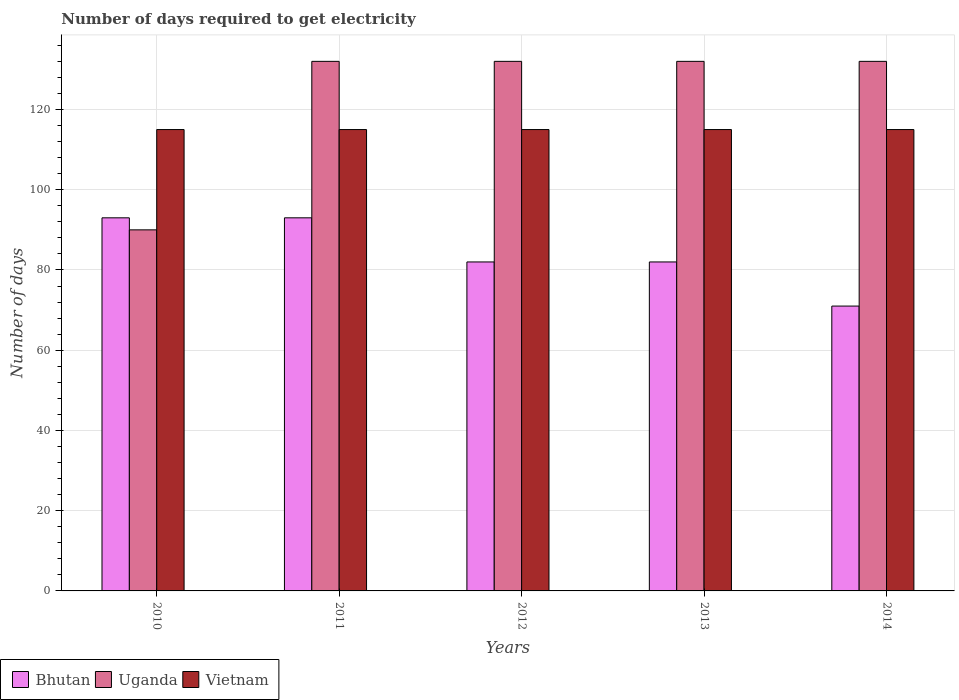Are the number of bars on each tick of the X-axis equal?
Provide a succinct answer. Yes. How many bars are there on the 5th tick from the left?
Ensure brevity in your answer.  3. What is the label of the 5th group of bars from the left?
Keep it short and to the point. 2014. In how many cases, is the number of bars for a given year not equal to the number of legend labels?
Make the answer very short. 0. What is the number of days required to get electricity in in Uganda in 2014?
Give a very brief answer. 132. Across all years, what is the maximum number of days required to get electricity in in Vietnam?
Make the answer very short. 115. Across all years, what is the minimum number of days required to get electricity in in Uganda?
Provide a short and direct response. 90. In which year was the number of days required to get electricity in in Vietnam maximum?
Your answer should be compact. 2010. In which year was the number of days required to get electricity in in Uganda minimum?
Give a very brief answer. 2010. What is the total number of days required to get electricity in in Vietnam in the graph?
Provide a succinct answer. 575. What is the difference between the number of days required to get electricity in in Uganda in 2011 and that in 2014?
Your response must be concise. 0. What is the difference between the number of days required to get electricity in in Bhutan in 2011 and the number of days required to get electricity in in Vietnam in 2010?
Your response must be concise. -22. What is the average number of days required to get electricity in in Bhutan per year?
Provide a succinct answer. 84.2. In the year 2013, what is the difference between the number of days required to get electricity in in Vietnam and number of days required to get electricity in in Uganda?
Your answer should be compact. -17. In how many years, is the number of days required to get electricity in in Bhutan greater than 8 days?
Your answer should be compact. 5. What is the ratio of the number of days required to get electricity in in Uganda in 2010 to that in 2014?
Make the answer very short. 0.68. Is the difference between the number of days required to get electricity in in Vietnam in 2011 and 2013 greater than the difference between the number of days required to get electricity in in Uganda in 2011 and 2013?
Give a very brief answer. No. What is the difference between the highest and the lowest number of days required to get electricity in in Bhutan?
Make the answer very short. 22. In how many years, is the number of days required to get electricity in in Vietnam greater than the average number of days required to get electricity in in Vietnam taken over all years?
Make the answer very short. 0. What does the 2nd bar from the left in 2010 represents?
Your response must be concise. Uganda. What does the 3rd bar from the right in 2014 represents?
Offer a terse response. Bhutan. Are all the bars in the graph horizontal?
Your answer should be compact. No. What is the difference between two consecutive major ticks on the Y-axis?
Keep it short and to the point. 20. Are the values on the major ticks of Y-axis written in scientific E-notation?
Ensure brevity in your answer.  No. Does the graph contain any zero values?
Offer a very short reply. No. How are the legend labels stacked?
Your answer should be very brief. Horizontal. What is the title of the graph?
Provide a succinct answer. Number of days required to get electricity. Does "Fragile and conflict affected situations" appear as one of the legend labels in the graph?
Your answer should be very brief. No. What is the label or title of the X-axis?
Provide a succinct answer. Years. What is the label or title of the Y-axis?
Your response must be concise. Number of days. What is the Number of days in Bhutan in 2010?
Provide a short and direct response. 93. What is the Number of days of Uganda in 2010?
Make the answer very short. 90. What is the Number of days in Vietnam in 2010?
Make the answer very short. 115. What is the Number of days of Bhutan in 2011?
Give a very brief answer. 93. What is the Number of days of Uganda in 2011?
Your answer should be very brief. 132. What is the Number of days in Vietnam in 2011?
Provide a succinct answer. 115. What is the Number of days of Uganda in 2012?
Your response must be concise. 132. What is the Number of days in Vietnam in 2012?
Provide a succinct answer. 115. What is the Number of days in Uganda in 2013?
Give a very brief answer. 132. What is the Number of days of Vietnam in 2013?
Your answer should be compact. 115. What is the Number of days in Bhutan in 2014?
Give a very brief answer. 71. What is the Number of days in Uganda in 2014?
Provide a succinct answer. 132. What is the Number of days in Vietnam in 2014?
Provide a succinct answer. 115. Across all years, what is the maximum Number of days of Bhutan?
Your answer should be very brief. 93. Across all years, what is the maximum Number of days of Uganda?
Provide a short and direct response. 132. Across all years, what is the maximum Number of days in Vietnam?
Provide a succinct answer. 115. Across all years, what is the minimum Number of days of Vietnam?
Your answer should be very brief. 115. What is the total Number of days of Bhutan in the graph?
Your answer should be compact. 421. What is the total Number of days of Uganda in the graph?
Your response must be concise. 618. What is the total Number of days of Vietnam in the graph?
Provide a succinct answer. 575. What is the difference between the Number of days in Bhutan in 2010 and that in 2011?
Ensure brevity in your answer.  0. What is the difference between the Number of days in Uganda in 2010 and that in 2011?
Keep it short and to the point. -42. What is the difference between the Number of days in Vietnam in 2010 and that in 2011?
Offer a very short reply. 0. What is the difference between the Number of days in Uganda in 2010 and that in 2012?
Ensure brevity in your answer.  -42. What is the difference between the Number of days in Vietnam in 2010 and that in 2012?
Provide a short and direct response. 0. What is the difference between the Number of days in Uganda in 2010 and that in 2013?
Ensure brevity in your answer.  -42. What is the difference between the Number of days in Vietnam in 2010 and that in 2013?
Your answer should be compact. 0. What is the difference between the Number of days of Bhutan in 2010 and that in 2014?
Your answer should be compact. 22. What is the difference between the Number of days in Uganda in 2010 and that in 2014?
Offer a terse response. -42. What is the difference between the Number of days in Vietnam in 2010 and that in 2014?
Offer a very short reply. 0. What is the difference between the Number of days in Bhutan in 2011 and that in 2012?
Provide a succinct answer. 11. What is the difference between the Number of days of Vietnam in 2011 and that in 2012?
Provide a short and direct response. 0. What is the difference between the Number of days of Vietnam in 2011 and that in 2013?
Offer a terse response. 0. What is the difference between the Number of days in Bhutan in 2012 and that in 2013?
Ensure brevity in your answer.  0. What is the difference between the Number of days of Vietnam in 2012 and that in 2013?
Keep it short and to the point. 0. What is the difference between the Number of days of Uganda in 2012 and that in 2014?
Keep it short and to the point. 0. What is the difference between the Number of days of Vietnam in 2012 and that in 2014?
Your answer should be compact. 0. What is the difference between the Number of days of Bhutan in 2013 and that in 2014?
Your answer should be very brief. 11. What is the difference between the Number of days of Uganda in 2013 and that in 2014?
Provide a succinct answer. 0. What is the difference between the Number of days of Vietnam in 2013 and that in 2014?
Ensure brevity in your answer.  0. What is the difference between the Number of days in Bhutan in 2010 and the Number of days in Uganda in 2011?
Your answer should be compact. -39. What is the difference between the Number of days of Bhutan in 2010 and the Number of days of Uganda in 2012?
Provide a succinct answer. -39. What is the difference between the Number of days in Bhutan in 2010 and the Number of days in Vietnam in 2012?
Your response must be concise. -22. What is the difference between the Number of days in Uganda in 2010 and the Number of days in Vietnam in 2012?
Offer a terse response. -25. What is the difference between the Number of days of Bhutan in 2010 and the Number of days of Uganda in 2013?
Your answer should be compact. -39. What is the difference between the Number of days of Uganda in 2010 and the Number of days of Vietnam in 2013?
Offer a very short reply. -25. What is the difference between the Number of days in Bhutan in 2010 and the Number of days in Uganda in 2014?
Make the answer very short. -39. What is the difference between the Number of days in Bhutan in 2010 and the Number of days in Vietnam in 2014?
Ensure brevity in your answer.  -22. What is the difference between the Number of days of Bhutan in 2011 and the Number of days of Uganda in 2012?
Provide a succinct answer. -39. What is the difference between the Number of days in Bhutan in 2011 and the Number of days in Vietnam in 2012?
Your response must be concise. -22. What is the difference between the Number of days of Uganda in 2011 and the Number of days of Vietnam in 2012?
Keep it short and to the point. 17. What is the difference between the Number of days of Bhutan in 2011 and the Number of days of Uganda in 2013?
Offer a very short reply. -39. What is the difference between the Number of days in Bhutan in 2011 and the Number of days in Uganda in 2014?
Your response must be concise. -39. What is the difference between the Number of days in Uganda in 2011 and the Number of days in Vietnam in 2014?
Provide a short and direct response. 17. What is the difference between the Number of days of Bhutan in 2012 and the Number of days of Vietnam in 2013?
Your response must be concise. -33. What is the difference between the Number of days in Bhutan in 2012 and the Number of days in Uganda in 2014?
Keep it short and to the point. -50. What is the difference between the Number of days in Bhutan in 2012 and the Number of days in Vietnam in 2014?
Your answer should be very brief. -33. What is the difference between the Number of days in Bhutan in 2013 and the Number of days in Vietnam in 2014?
Provide a succinct answer. -33. What is the difference between the Number of days in Uganda in 2013 and the Number of days in Vietnam in 2014?
Provide a succinct answer. 17. What is the average Number of days in Bhutan per year?
Ensure brevity in your answer.  84.2. What is the average Number of days in Uganda per year?
Ensure brevity in your answer.  123.6. What is the average Number of days in Vietnam per year?
Your response must be concise. 115. In the year 2010, what is the difference between the Number of days in Uganda and Number of days in Vietnam?
Keep it short and to the point. -25. In the year 2011, what is the difference between the Number of days of Bhutan and Number of days of Uganda?
Ensure brevity in your answer.  -39. In the year 2012, what is the difference between the Number of days of Bhutan and Number of days of Uganda?
Provide a short and direct response. -50. In the year 2012, what is the difference between the Number of days in Bhutan and Number of days in Vietnam?
Your response must be concise. -33. In the year 2013, what is the difference between the Number of days of Bhutan and Number of days of Vietnam?
Offer a very short reply. -33. In the year 2013, what is the difference between the Number of days in Uganda and Number of days in Vietnam?
Offer a terse response. 17. In the year 2014, what is the difference between the Number of days in Bhutan and Number of days in Uganda?
Your answer should be very brief. -61. In the year 2014, what is the difference between the Number of days in Bhutan and Number of days in Vietnam?
Offer a terse response. -44. What is the ratio of the Number of days of Uganda in 2010 to that in 2011?
Make the answer very short. 0.68. What is the ratio of the Number of days in Bhutan in 2010 to that in 2012?
Provide a succinct answer. 1.13. What is the ratio of the Number of days of Uganda in 2010 to that in 2012?
Offer a terse response. 0.68. What is the ratio of the Number of days in Vietnam in 2010 to that in 2012?
Your answer should be very brief. 1. What is the ratio of the Number of days in Bhutan in 2010 to that in 2013?
Offer a terse response. 1.13. What is the ratio of the Number of days of Uganda in 2010 to that in 2013?
Give a very brief answer. 0.68. What is the ratio of the Number of days of Bhutan in 2010 to that in 2014?
Offer a terse response. 1.31. What is the ratio of the Number of days in Uganda in 2010 to that in 2014?
Ensure brevity in your answer.  0.68. What is the ratio of the Number of days in Bhutan in 2011 to that in 2012?
Make the answer very short. 1.13. What is the ratio of the Number of days in Uganda in 2011 to that in 2012?
Your answer should be compact. 1. What is the ratio of the Number of days of Bhutan in 2011 to that in 2013?
Offer a terse response. 1.13. What is the ratio of the Number of days of Uganda in 2011 to that in 2013?
Offer a terse response. 1. What is the ratio of the Number of days of Bhutan in 2011 to that in 2014?
Ensure brevity in your answer.  1.31. What is the ratio of the Number of days in Uganda in 2011 to that in 2014?
Your response must be concise. 1. What is the ratio of the Number of days of Uganda in 2012 to that in 2013?
Make the answer very short. 1. What is the ratio of the Number of days of Bhutan in 2012 to that in 2014?
Your answer should be very brief. 1.15. What is the ratio of the Number of days in Uganda in 2012 to that in 2014?
Offer a very short reply. 1. What is the ratio of the Number of days of Vietnam in 2012 to that in 2014?
Provide a short and direct response. 1. What is the ratio of the Number of days of Bhutan in 2013 to that in 2014?
Offer a very short reply. 1.15. What is the difference between the highest and the second highest Number of days in Uganda?
Ensure brevity in your answer.  0. What is the difference between the highest and the lowest Number of days in Uganda?
Offer a very short reply. 42. 